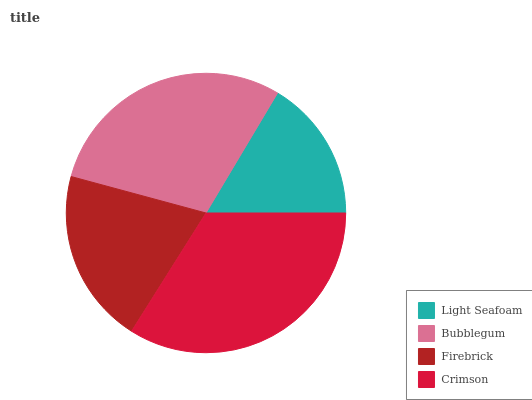Is Light Seafoam the minimum?
Answer yes or no. Yes. Is Crimson the maximum?
Answer yes or no. Yes. Is Bubblegum the minimum?
Answer yes or no. No. Is Bubblegum the maximum?
Answer yes or no. No. Is Bubblegum greater than Light Seafoam?
Answer yes or no. Yes. Is Light Seafoam less than Bubblegum?
Answer yes or no. Yes. Is Light Seafoam greater than Bubblegum?
Answer yes or no. No. Is Bubblegum less than Light Seafoam?
Answer yes or no. No. Is Bubblegum the high median?
Answer yes or no. Yes. Is Firebrick the low median?
Answer yes or no. Yes. Is Crimson the high median?
Answer yes or no. No. Is Light Seafoam the low median?
Answer yes or no. No. 